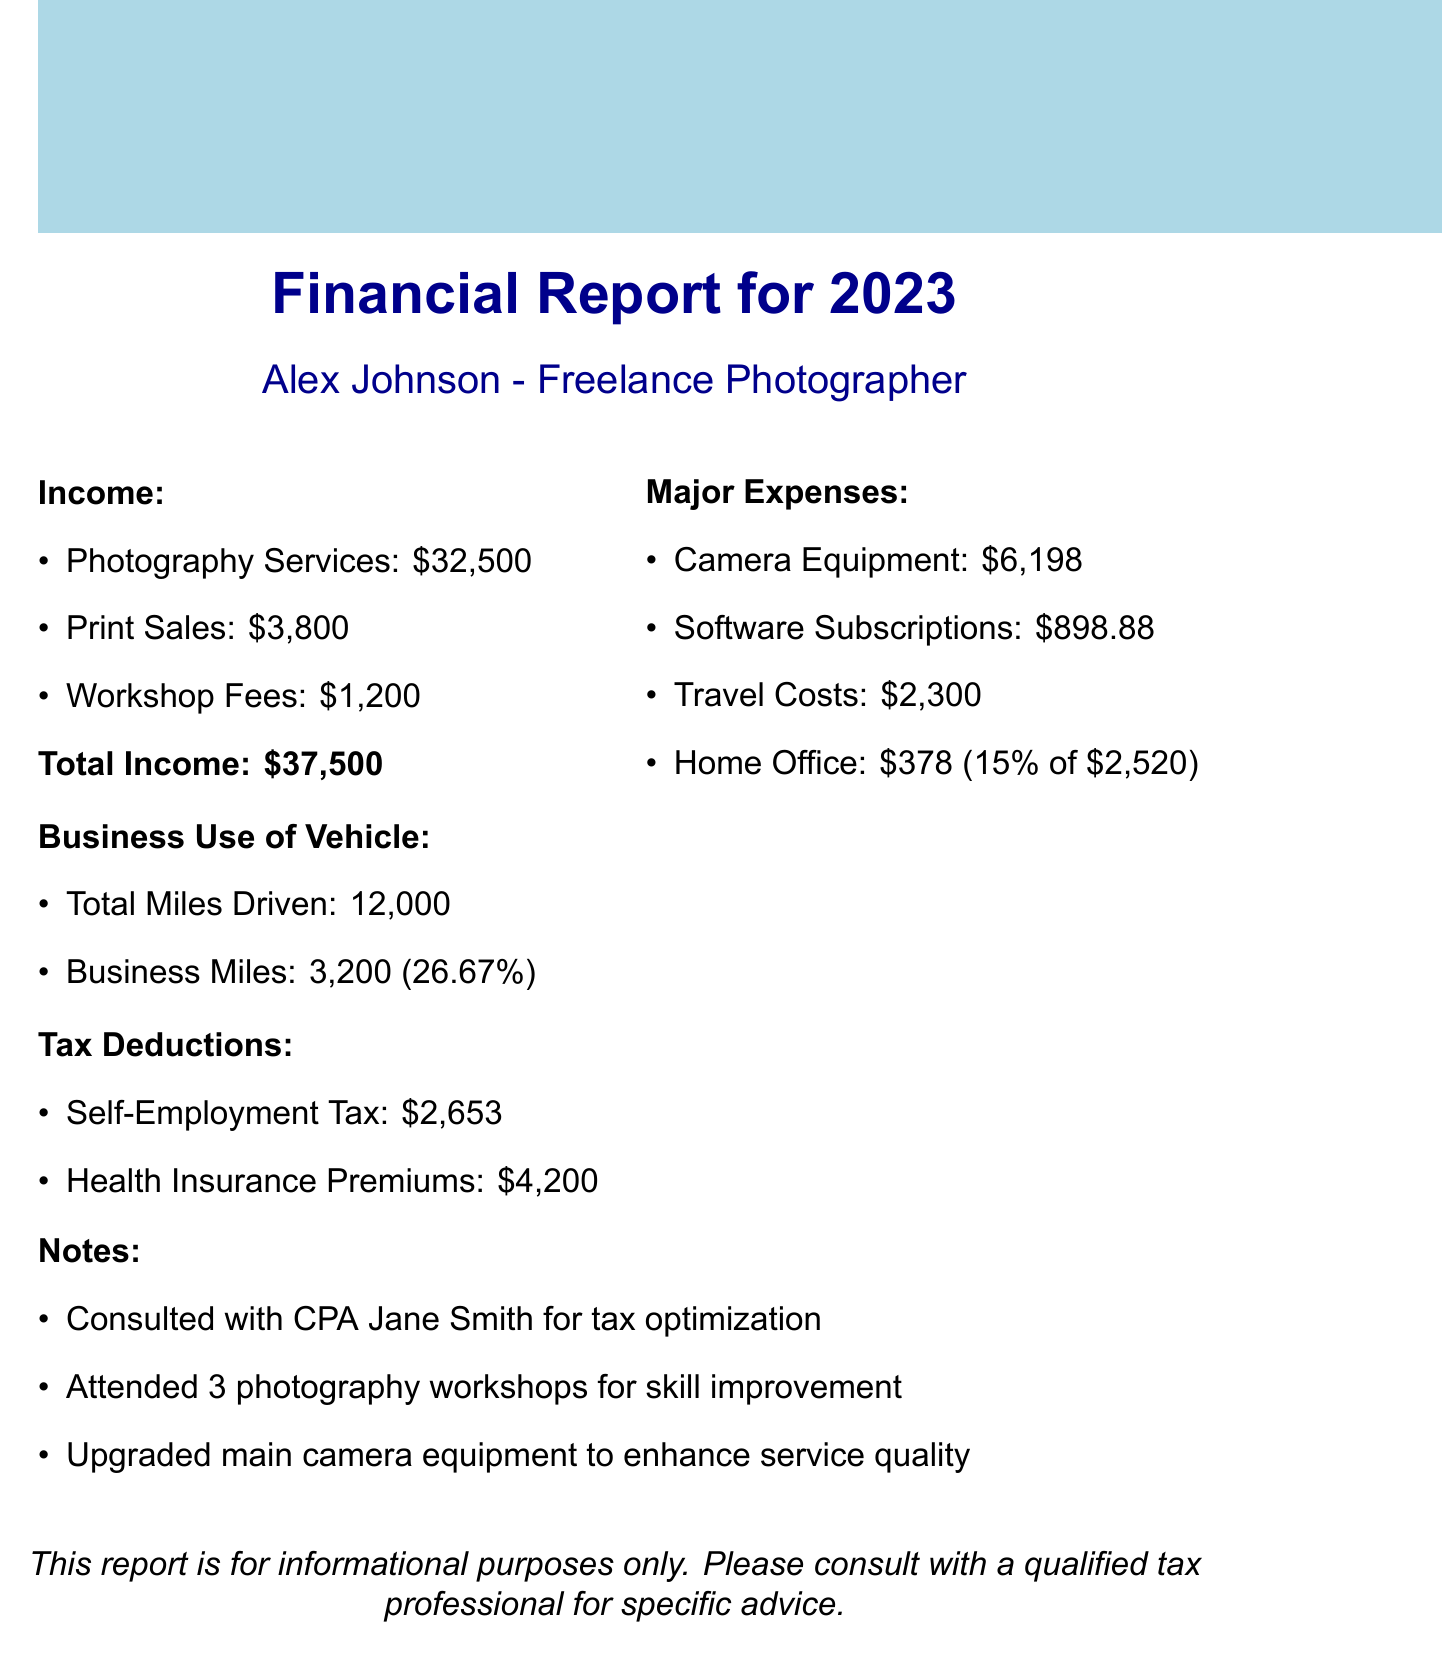what is the total income? The total income is the sum of all income sources in the document, which is $32,500 + $3,800 + $1,200 = $37,500.
Answer: $37,500 how much was spent on camera equipment? The expense for camera equipment is detailed in the document as $3,899 for the Camera EOS R5 and $2,299 for the Canon RF lens, totaling $6,198.
Answer: $6,198 what is the percentage of home office deduction? The home office deduction percentage is given as 15% based on the percentage of the home used for business.
Answer: 15% how much was deducted for health insurance premiums? The document specifies that health insurance premiums deduction amounts to $4,200.
Answer: $4,200 what percentage of total miles driven were business miles? The document shows that the business miles are 3,200 out of a total of 12,000 miles driven, which is 26.67%.
Answer: 26.67% how many photography workshops did Alex attend? The notes section states that Alex attended 3 photography workshops for skill improvement.
Answer: 3 what is the total expense for software subscriptions? The total expense for software subscriptions is detailed as $599.88 for Adobe Creative Cloud and $299 for Capture One Pro, totaling $898.88.
Answer: $898.88 who did Alex consult for tax optimization? The notes indicate that Alex consulted with CPA Jane Smith for tax optimization.
Answer: CPA Jane Smith what is the total expense for travel costs? The travel costs are detailed as mileage of $3,200, accommodation of $1,500, and meals of $800, totaling $2,300 for travel costs.
Answer: $2,300 